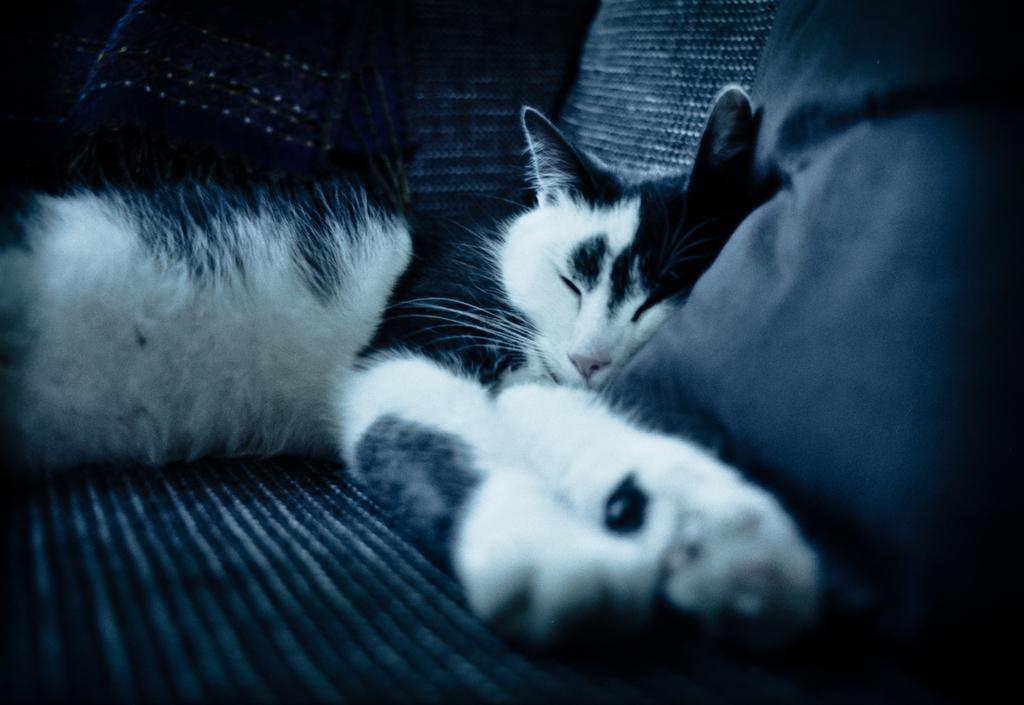Could you give a brief overview of what you see in this image? In this picture there is a cat sleeping in sofa and there is a pillow in the right corner. 